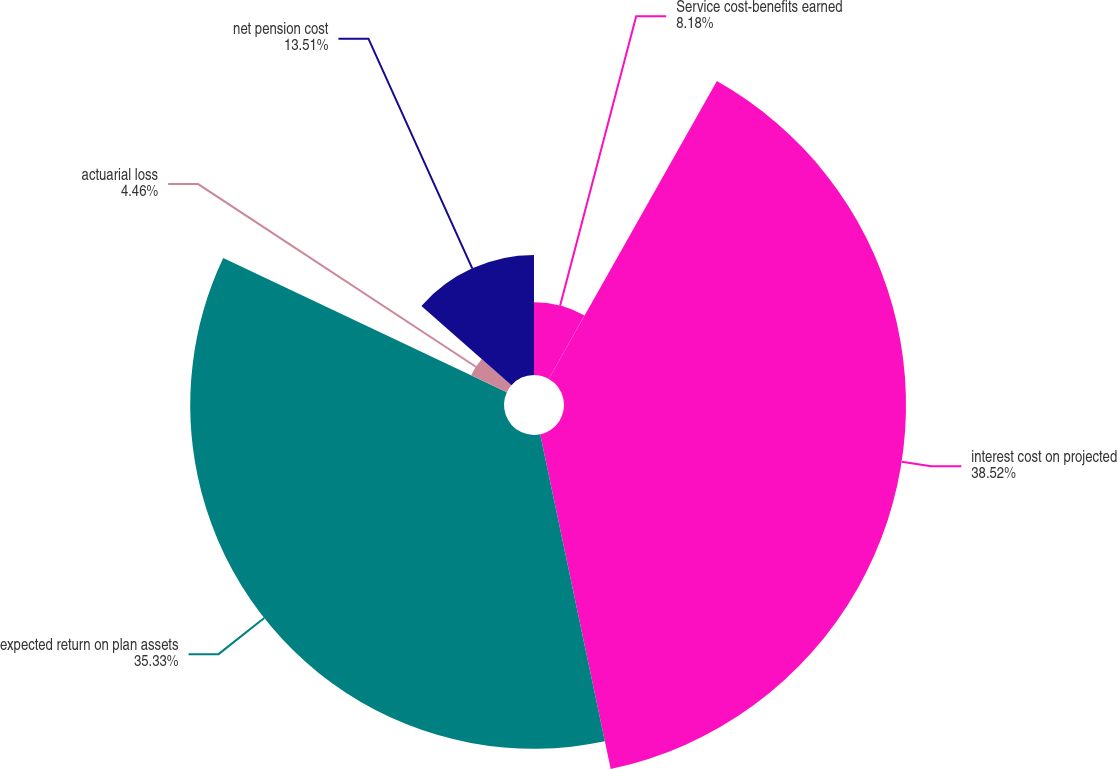Convert chart to OTSL. <chart><loc_0><loc_0><loc_500><loc_500><pie_chart><fcel>Service cost-benefits earned<fcel>interest cost on projected<fcel>expected return on plan assets<fcel>actuarial loss<fcel>net pension cost<nl><fcel>8.18%<fcel>38.51%<fcel>35.33%<fcel>4.46%<fcel>13.51%<nl></chart> 